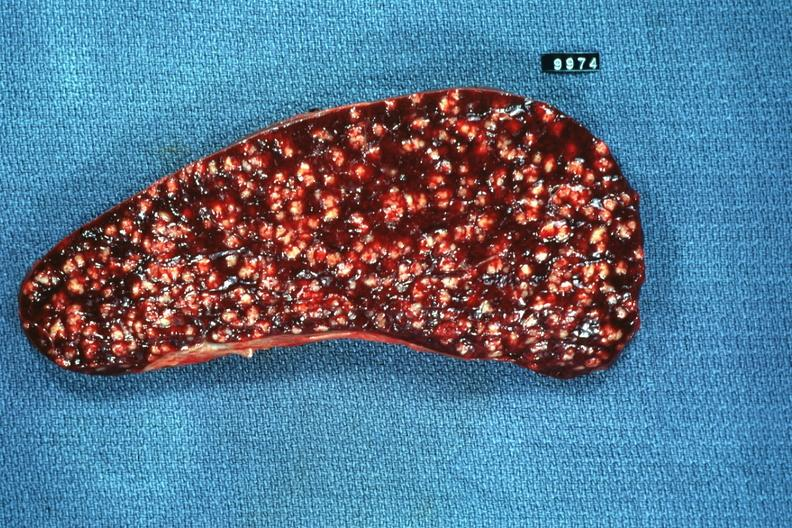s carcinoma metastatic lung present?
Answer the question using a single word or phrase. No 